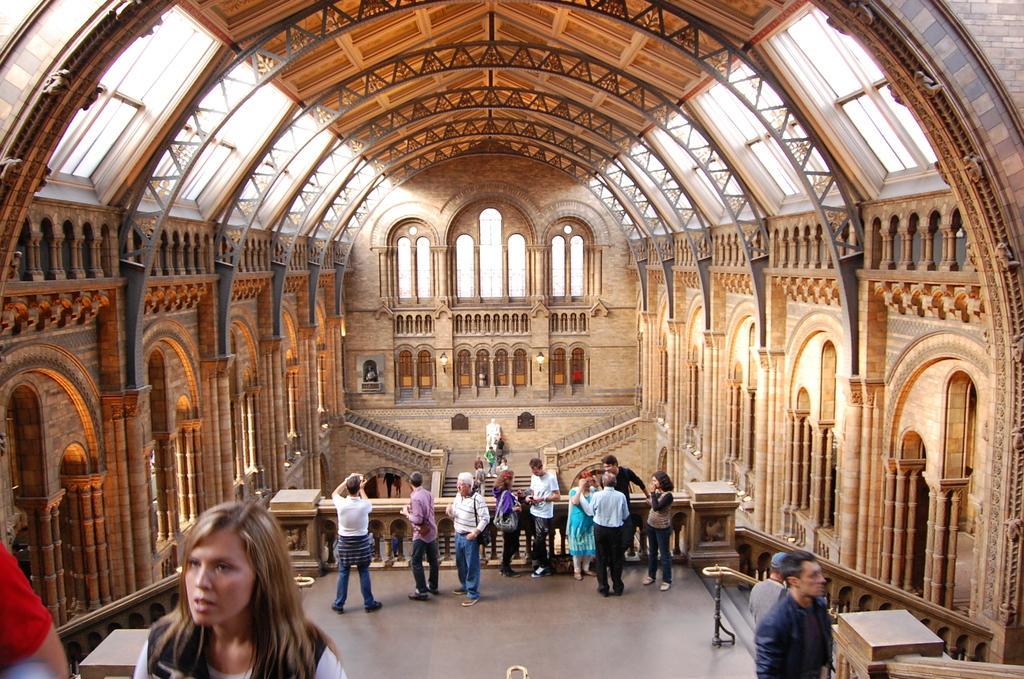How many people are standing in the image? There are people standing in the image, but the exact number is not specified. What surface are the people standing on? The people are standing on the floor. What is above the people in the image? There is a ceiling visible in the image. What architectural features can be seen in the image? Pillars and steps are present in the image. What type of artwork is visible in the background? Stained glass is visible in the background. What other objects are present in the image? There is a statue and lamps in the image. Can you tell me which person's eye is bigger in the image? There is no information about the size of the people's eyes in the image, so it cannot be determined. 